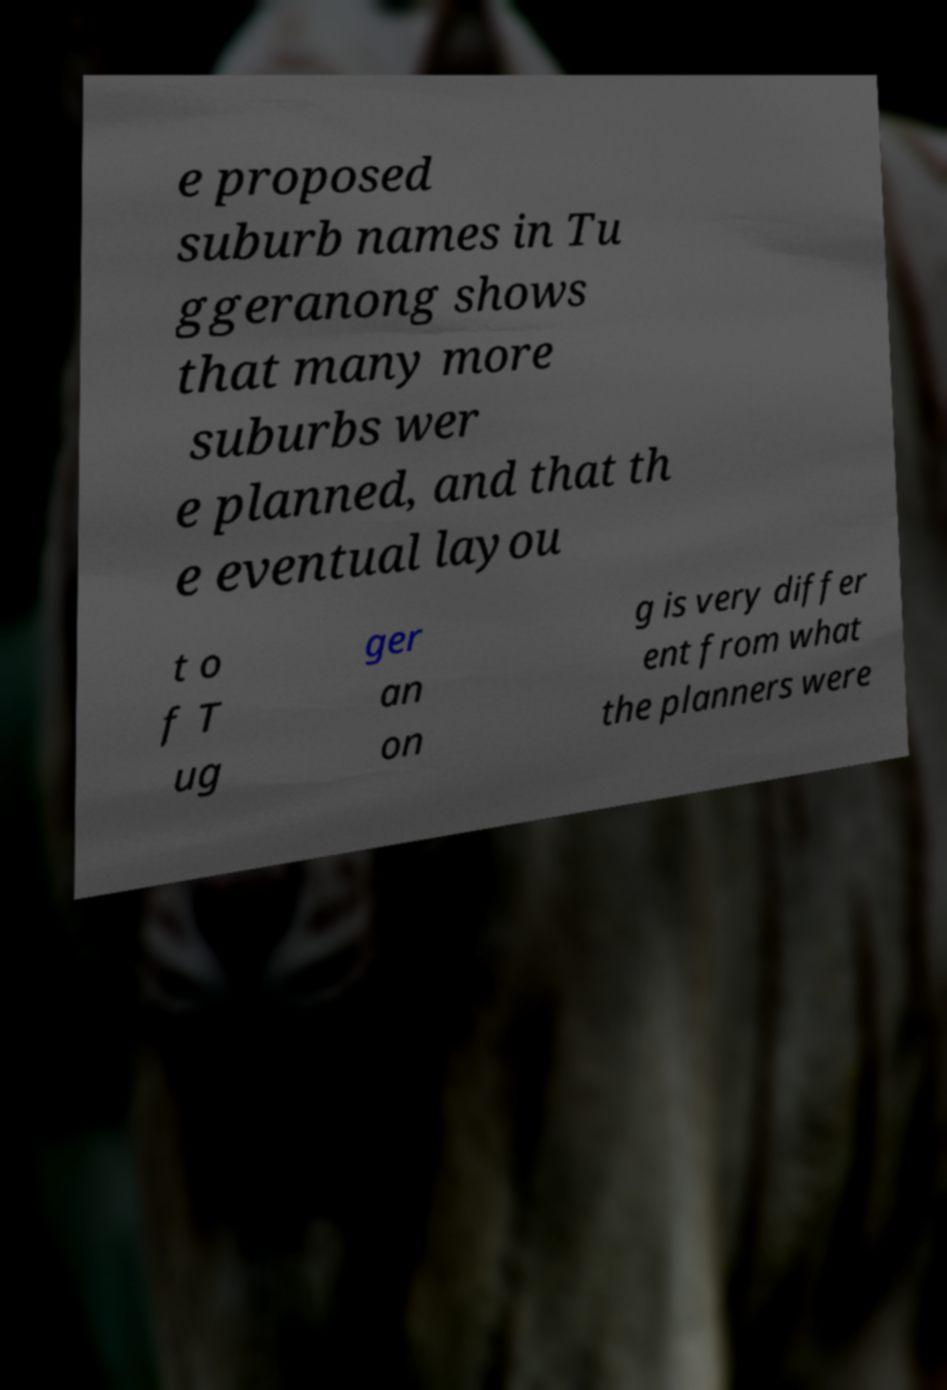Could you assist in decoding the text presented in this image and type it out clearly? e proposed suburb names in Tu ggeranong shows that many more suburbs wer e planned, and that th e eventual layou t o f T ug ger an on g is very differ ent from what the planners were 